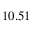<formula> <loc_0><loc_0><loc_500><loc_500>1 0 . 5 1 \</formula> 